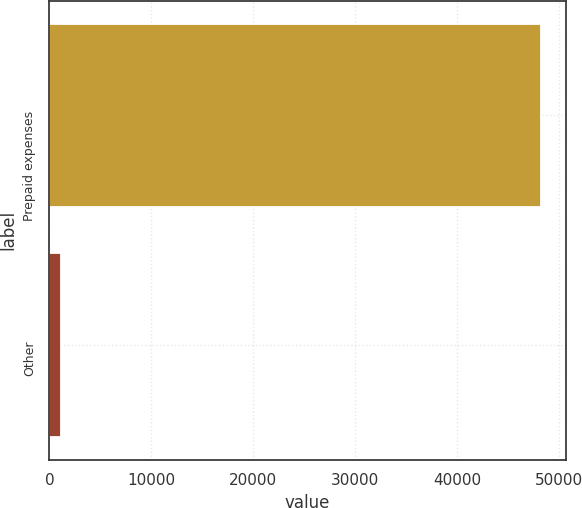Convert chart. <chart><loc_0><loc_0><loc_500><loc_500><bar_chart><fcel>Prepaid expenses<fcel>Other<nl><fcel>48256<fcel>1093<nl></chart> 